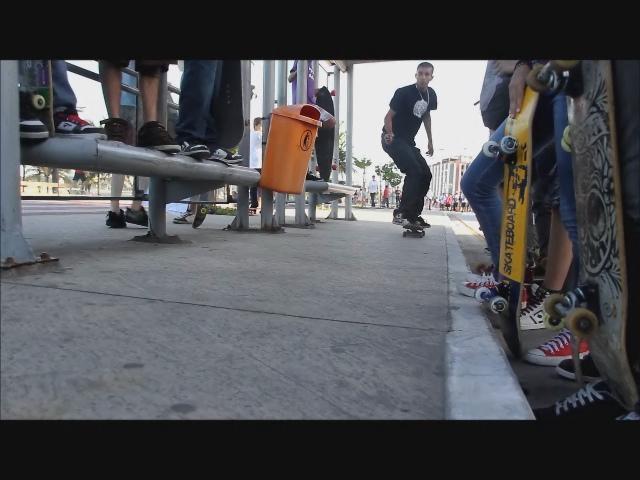How many skateboards can be seen?
Give a very brief answer. 2. How many people are there?
Give a very brief answer. 8. How many benches are in the photo?
Give a very brief answer. 2. How many bananas are on the table?
Give a very brief answer. 0. 